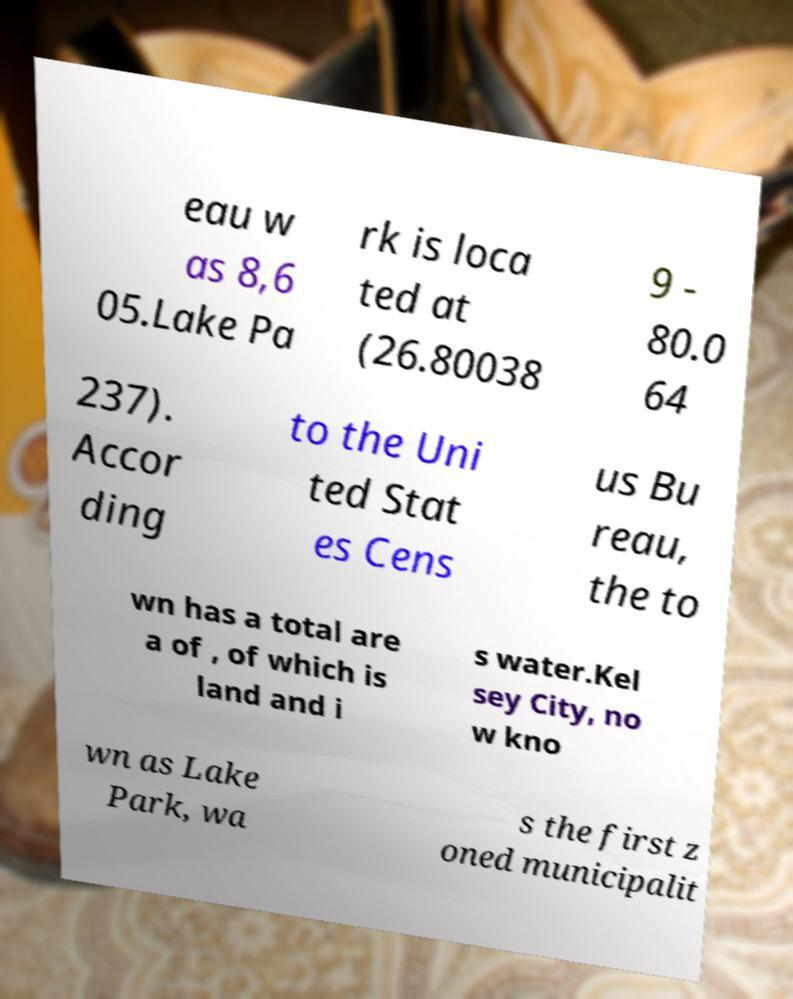For documentation purposes, I need the text within this image transcribed. Could you provide that? eau w as 8,6 05.Lake Pa rk is loca ted at (26.80038 9 - 80.0 64 237). Accor ding to the Uni ted Stat es Cens us Bu reau, the to wn has a total are a of , of which is land and i s water.Kel sey City, no w kno wn as Lake Park, wa s the first z oned municipalit 